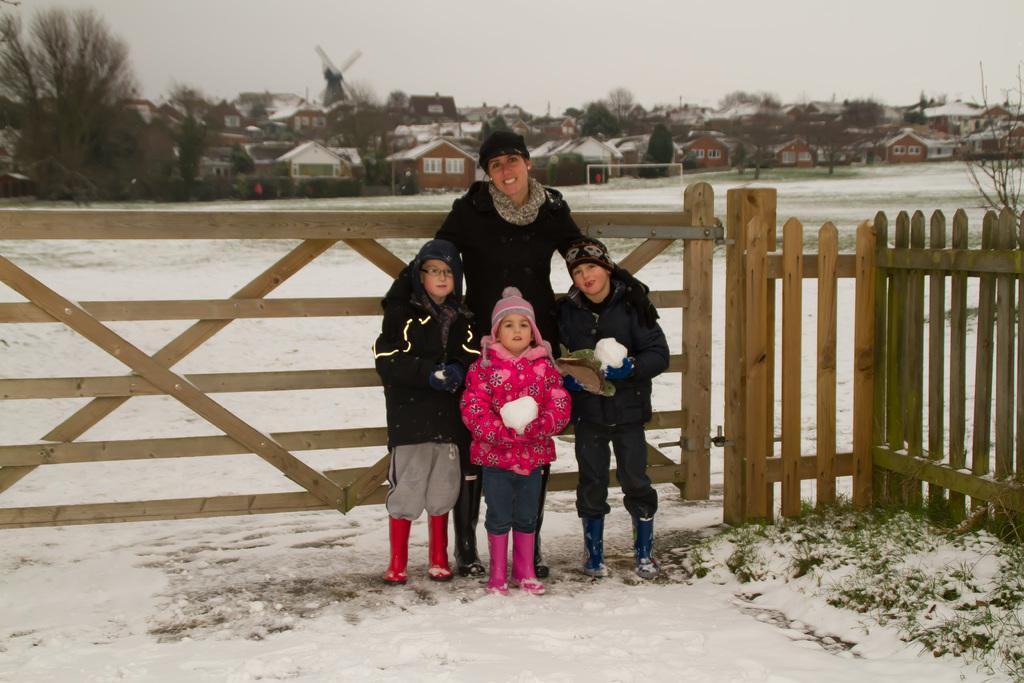Please provide a concise description of this image. In the picture I can see a person and children are standing on the ground. In the background I can see wooden fence, the snow, houses, trees, the sky and some other objects. 